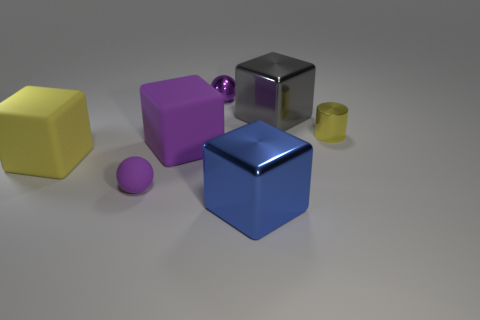Are any metallic cylinders visible?
Offer a very short reply. Yes. Are there more big metallic blocks that are in front of the small purple rubber sphere than large rubber things on the right side of the big blue object?
Make the answer very short. Yes. There is a big gray object that is the same shape as the blue metallic object; what is it made of?
Your answer should be very brief. Metal. Is the color of the small metal thing that is to the left of the blue cube the same as the small object to the right of the small purple metal thing?
Give a very brief answer. No. There is a big yellow object; what shape is it?
Your answer should be very brief. Cube. Is the number of large gray cubes that are behind the gray shiny thing greater than the number of cyan matte cylinders?
Provide a succinct answer. No. The purple matte thing on the right side of the tiny matte object has what shape?
Your response must be concise. Cube. What number of other things are the same shape as the tiny yellow object?
Offer a terse response. 0. Do the small purple sphere that is to the left of the shiny ball and the yellow cylinder have the same material?
Provide a succinct answer. No. Are there the same number of blue things behind the purple shiny object and large things that are behind the blue metallic object?
Provide a short and direct response. No. 